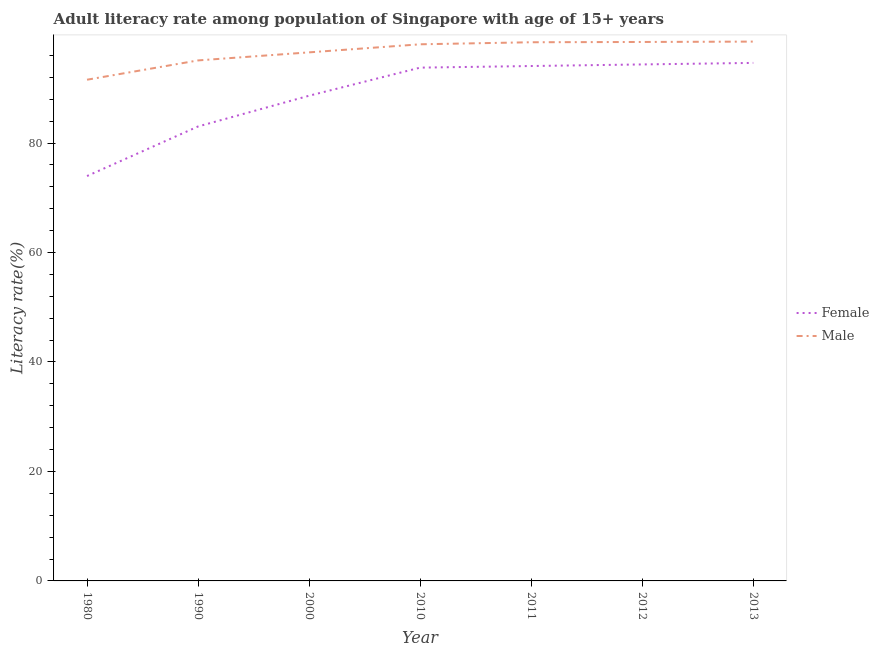How many different coloured lines are there?
Offer a terse response. 2. Is the number of lines equal to the number of legend labels?
Give a very brief answer. Yes. What is the male adult literacy rate in 2011?
Offer a terse response. 98.41. Across all years, what is the maximum female adult literacy rate?
Provide a short and direct response. 94.64. Across all years, what is the minimum female adult literacy rate?
Ensure brevity in your answer.  73.97. In which year was the female adult literacy rate maximum?
Keep it short and to the point. 2013. In which year was the male adult literacy rate minimum?
Offer a terse response. 1980. What is the total male adult literacy rate in the graph?
Offer a very short reply. 676.67. What is the difference between the male adult literacy rate in 2011 and that in 2012?
Provide a succinct answer. -0.05. What is the difference between the female adult literacy rate in 2012 and the male adult literacy rate in 2000?
Offer a terse response. -2.21. What is the average female adult literacy rate per year?
Provide a succinct answer. 88.93. In the year 2011, what is the difference between the male adult literacy rate and female adult literacy rate?
Give a very brief answer. 4.34. What is the ratio of the male adult literacy rate in 2011 to that in 2013?
Offer a very short reply. 1. Is the difference between the female adult literacy rate in 1980 and 2000 greater than the difference between the male adult literacy rate in 1980 and 2000?
Offer a very short reply. No. What is the difference between the highest and the second highest female adult literacy rate?
Provide a succinct answer. 0.28. What is the difference between the highest and the lowest male adult literacy rate?
Keep it short and to the point. 6.96. In how many years, is the male adult literacy rate greater than the average male adult literacy rate taken over all years?
Give a very brief answer. 4. Does the male adult literacy rate monotonically increase over the years?
Offer a terse response. Yes. Is the male adult literacy rate strictly greater than the female adult literacy rate over the years?
Give a very brief answer. Yes. Is the female adult literacy rate strictly less than the male adult literacy rate over the years?
Offer a terse response. Yes. How many lines are there?
Keep it short and to the point. 2. What is the difference between two consecutive major ticks on the Y-axis?
Your answer should be very brief. 20. Where does the legend appear in the graph?
Your response must be concise. Center right. How are the legend labels stacked?
Provide a succinct answer. Vertical. What is the title of the graph?
Your answer should be compact. Adult literacy rate among population of Singapore with age of 15+ years. What is the label or title of the X-axis?
Provide a short and direct response. Year. What is the label or title of the Y-axis?
Offer a very short reply. Literacy rate(%). What is the Literacy rate(%) in Female in 1980?
Provide a short and direct response. 73.97. What is the Literacy rate(%) of Male in 1980?
Give a very brief answer. 91.57. What is the Literacy rate(%) of Female in 1990?
Offer a very short reply. 83.03. What is the Literacy rate(%) in Male in 1990?
Offer a very short reply. 95.09. What is the Literacy rate(%) of Female in 2000?
Your answer should be very brief. 88.65. What is the Literacy rate(%) in Male in 2000?
Provide a succinct answer. 96.57. What is the Literacy rate(%) of Female in 2010?
Your response must be concise. 93.77. What is the Literacy rate(%) in Male in 2010?
Your answer should be compact. 98.04. What is the Literacy rate(%) in Female in 2011?
Keep it short and to the point. 94.07. What is the Literacy rate(%) in Male in 2011?
Ensure brevity in your answer.  98.41. What is the Literacy rate(%) in Female in 2012?
Offer a terse response. 94.36. What is the Literacy rate(%) of Male in 2012?
Your answer should be very brief. 98.46. What is the Literacy rate(%) in Female in 2013?
Keep it short and to the point. 94.64. What is the Literacy rate(%) of Male in 2013?
Ensure brevity in your answer.  98.53. Across all years, what is the maximum Literacy rate(%) of Female?
Your answer should be compact. 94.64. Across all years, what is the maximum Literacy rate(%) of Male?
Give a very brief answer. 98.53. Across all years, what is the minimum Literacy rate(%) in Female?
Keep it short and to the point. 73.97. Across all years, what is the minimum Literacy rate(%) in Male?
Provide a succinct answer. 91.57. What is the total Literacy rate(%) of Female in the graph?
Your response must be concise. 622.48. What is the total Literacy rate(%) in Male in the graph?
Make the answer very short. 676.67. What is the difference between the Literacy rate(%) of Female in 1980 and that in 1990?
Give a very brief answer. -9.06. What is the difference between the Literacy rate(%) of Male in 1980 and that in 1990?
Make the answer very short. -3.53. What is the difference between the Literacy rate(%) in Female in 1980 and that in 2000?
Make the answer very short. -14.68. What is the difference between the Literacy rate(%) in Male in 1980 and that in 2000?
Make the answer very short. -5. What is the difference between the Literacy rate(%) of Female in 1980 and that in 2010?
Ensure brevity in your answer.  -19.81. What is the difference between the Literacy rate(%) of Male in 1980 and that in 2010?
Make the answer very short. -6.47. What is the difference between the Literacy rate(%) in Female in 1980 and that in 2011?
Your response must be concise. -20.1. What is the difference between the Literacy rate(%) of Male in 1980 and that in 2011?
Make the answer very short. -6.85. What is the difference between the Literacy rate(%) of Female in 1980 and that in 2012?
Provide a short and direct response. -20.39. What is the difference between the Literacy rate(%) of Male in 1980 and that in 2012?
Offer a very short reply. -6.9. What is the difference between the Literacy rate(%) in Female in 1980 and that in 2013?
Give a very brief answer. -20.67. What is the difference between the Literacy rate(%) in Male in 1980 and that in 2013?
Give a very brief answer. -6.96. What is the difference between the Literacy rate(%) in Female in 1990 and that in 2000?
Give a very brief answer. -5.62. What is the difference between the Literacy rate(%) of Male in 1990 and that in 2000?
Your answer should be compact. -1.47. What is the difference between the Literacy rate(%) of Female in 1990 and that in 2010?
Offer a very short reply. -10.75. What is the difference between the Literacy rate(%) in Male in 1990 and that in 2010?
Your answer should be very brief. -2.94. What is the difference between the Literacy rate(%) of Female in 1990 and that in 2011?
Your response must be concise. -11.04. What is the difference between the Literacy rate(%) in Male in 1990 and that in 2011?
Ensure brevity in your answer.  -3.32. What is the difference between the Literacy rate(%) in Female in 1990 and that in 2012?
Give a very brief answer. -11.33. What is the difference between the Literacy rate(%) of Male in 1990 and that in 2012?
Ensure brevity in your answer.  -3.37. What is the difference between the Literacy rate(%) of Female in 1990 and that in 2013?
Ensure brevity in your answer.  -11.61. What is the difference between the Literacy rate(%) in Male in 1990 and that in 2013?
Give a very brief answer. -3.44. What is the difference between the Literacy rate(%) in Female in 2000 and that in 2010?
Provide a succinct answer. -5.13. What is the difference between the Literacy rate(%) of Male in 2000 and that in 2010?
Ensure brevity in your answer.  -1.47. What is the difference between the Literacy rate(%) of Female in 2000 and that in 2011?
Offer a terse response. -5.42. What is the difference between the Literacy rate(%) in Male in 2000 and that in 2011?
Give a very brief answer. -1.85. What is the difference between the Literacy rate(%) of Female in 2000 and that in 2012?
Provide a short and direct response. -5.71. What is the difference between the Literacy rate(%) in Male in 2000 and that in 2012?
Offer a very short reply. -1.9. What is the difference between the Literacy rate(%) of Female in 2000 and that in 2013?
Give a very brief answer. -5.99. What is the difference between the Literacy rate(%) in Male in 2000 and that in 2013?
Your answer should be compact. -1.97. What is the difference between the Literacy rate(%) in Female in 2010 and that in 2011?
Offer a terse response. -0.29. What is the difference between the Literacy rate(%) in Male in 2010 and that in 2011?
Your response must be concise. -0.37. What is the difference between the Literacy rate(%) of Female in 2010 and that in 2012?
Provide a short and direct response. -0.58. What is the difference between the Literacy rate(%) of Male in 2010 and that in 2012?
Your response must be concise. -0.43. What is the difference between the Literacy rate(%) of Female in 2010 and that in 2013?
Offer a very short reply. -0.86. What is the difference between the Literacy rate(%) in Male in 2010 and that in 2013?
Offer a terse response. -0.49. What is the difference between the Literacy rate(%) in Female in 2011 and that in 2012?
Offer a terse response. -0.29. What is the difference between the Literacy rate(%) in Male in 2011 and that in 2012?
Provide a short and direct response. -0.05. What is the difference between the Literacy rate(%) of Female in 2011 and that in 2013?
Ensure brevity in your answer.  -0.57. What is the difference between the Literacy rate(%) in Male in 2011 and that in 2013?
Your response must be concise. -0.12. What is the difference between the Literacy rate(%) of Female in 2012 and that in 2013?
Your response must be concise. -0.28. What is the difference between the Literacy rate(%) in Male in 2012 and that in 2013?
Offer a very short reply. -0.07. What is the difference between the Literacy rate(%) in Female in 1980 and the Literacy rate(%) in Male in 1990?
Provide a short and direct response. -21.12. What is the difference between the Literacy rate(%) in Female in 1980 and the Literacy rate(%) in Male in 2000?
Your answer should be very brief. -22.6. What is the difference between the Literacy rate(%) of Female in 1980 and the Literacy rate(%) of Male in 2010?
Offer a very short reply. -24.07. What is the difference between the Literacy rate(%) of Female in 1980 and the Literacy rate(%) of Male in 2011?
Provide a short and direct response. -24.44. What is the difference between the Literacy rate(%) in Female in 1980 and the Literacy rate(%) in Male in 2012?
Provide a short and direct response. -24.49. What is the difference between the Literacy rate(%) in Female in 1980 and the Literacy rate(%) in Male in 2013?
Offer a very short reply. -24.56. What is the difference between the Literacy rate(%) of Female in 1990 and the Literacy rate(%) of Male in 2000?
Offer a very short reply. -13.54. What is the difference between the Literacy rate(%) in Female in 1990 and the Literacy rate(%) in Male in 2010?
Keep it short and to the point. -15.01. What is the difference between the Literacy rate(%) of Female in 1990 and the Literacy rate(%) of Male in 2011?
Make the answer very short. -15.38. What is the difference between the Literacy rate(%) of Female in 1990 and the Literacy rate(%) of Male in 2012?
Make the answer very short. -15.44. What is the difference between the Literacy rate(%) of Female in 1990 and the Literacy rate(%) of Male in 2013?
Your answer should be compact. -15.5. What is the difference between the Literacy rate(%) of Female in 2000 and the Literacy rate(%) of Male in 2010?
Your answer should be very brief. -9.39. What is the difference between the Literacy rate(%) in Female in 2000 and the Literacy rate(%) in Male in 2011?
Your response must be concise. -9.77. What is the difference between the Literacy rate(%) of Female in 2000 and the Literacy rate(%) of Male in 2012?
Offer a terse response. -9.82. What is the difference between the Literacy rate(%) in Female in 2000 and the Literacy rate(%) in Male in 2013?
Provide a succinct answer. -9.89. What is the difference between the Literacy rate(%) in Female in 2010 and the Literacy rate(%) in Male in 2011?
Offer a very short reply. -4.64. What is the difference between the Literacy rate(%) of Female in 2010 and the Literacy rate(%) of Male in 2012?
Offer a very short reply. -4.69. What is the difference between the Literacy rate(%) of Female in 2010 and the Literacy rate(%) of Male in 2013?
Offer a terse response. -4.76. What is the difference between the Literacy rate(%) in Female in 2011 and the Literacy rate(%) in Male in 2012?
Offer a terse response. -4.39. What is the difference between the Literacy rate(%) of Female in 2011 and the Literacy rate(%) of Male in 2013?
Your answer should be compact. -4.46. What is the difference between the Literacy rate(%) in Female in 2012 and the Literacy rate(%) in Male in 2013?
Provide a short and direct response. -4.17. What is the average Literacy rate(%) of Female per year?
Your answer should be very brief. 88.93. What is the average Literacy rate(%) in Male per year?
Keep it short and to the point. 96.67. In the year 1980, what is the difference between the Literacy rate(%) in Female and Literacy rate(%) in Male?
Your response must be concise. -17.6. In the year 1990, what is the difference between the Literacy rate(%) in Female and Literacy rate(%) in Male?
Provide a short and direct response. -12.07. In the year 2000, what is the difference between the Literacy rate(%) in Female and Literacy rate(%) in Male?
Give a very brief answer. -7.92. In the year 2010, what is the difference between the Literacy rate(%) in Female and Literacy rate(%) in Male?
Your answer should be very brief. -4.26. In the year 2011, what is the difference between the Literacy rate(%) in Female and Literacy rate(%) in Male?
Your response must be concise. -4.34. In the year 2012, what is the difference between the Literacy rate(%) of Female and Literacy rate(%) of Male?
Your answer should be very brief. -4.1. In the year 2013, what is the difference between the Literacy rate(%) in Female and Literacy rate(%) in Male?
Your answer should be compact. -3.89. What is the ratio of the Literacy rate(%) of Female in 1980 to that in 1990?
Provide a succinct answer. 0.89. What is the ratio of the Literacy rate(%) of Male in 1980 to that in 1990?
Keep it short and to the point. 0.96. What is the ratio of the Literacy rate(%) of Female in 1980 to that in 2000?
Ensure brevity in your answer.  0.83. What is the ratio of the Literacy rate(%) in Male in 1980 to that in 2000?
Offer a terse response. 0.95. What is the ratio of the Literacy rate(%) in Female in 1980 to that in 2010?
Offer a very short reply. 0.79. What is the ratio of the Literacy rate(%) in Male in 1980 to that in 2010?
Keep it short and to the point. 0.93. What is the ratio of the Literacy rate(%) of Female in 1980 to that in 2011?
Provide a succinct answer. 0.79. What is the ratio of the Literacy rate(%) in Male in 1980 to that in 2011?
Your answer should be compact. 0.93. What is the ratio of the Literacy rate(%) in Female in 1980 to that in 2012?
Make the answer very short. 0.78. What is the ratio of the Literacy rate(%) of Female in 1980 to that in 2013?
Keep it short and to the point. 0.78. What is the ratio of the Literacy rate(%) in Male in 1980 to that in 2013?
Give a very brief answer. 0.93. What is the ratio of the Literacy rate(%) of Female in 1990 to that in 2000?
Your answer should be very brief. 0.94. What is the ratio of the Literacy rate(%) of Female in 1990 to that in 2010?
Your response must be concise. 0.89. What is the ratio of the Literacy rate(%) of Male in 1990 to that in 2010?
Keep it short and to the point. 0.97. What is the ratio of the Literacy rate(%) of Female in 1990 to that in 2011?
Give a very brief answer. 0.88. What is the ratio of the Literacy rate(%) of Male in 1990 to that in 2011?
Offer a very short reply. 0.97. What is the ratio of the Literacy rate(%) of Female in 1990 to that in 2012?
Your answer should be very brief. 0.88. What is the ratio of the Literacy rate(%) of Male in 1990 to that in 2012?
Provide a short and direct response. 0.97. What is the ratio of the Literacy rate(%) of Female in 1990 to that in 2013?
Ensure brevity in your answer.  0.88. What is the ratio of the Literacy rate(%) in Male in 1990 to that in 2013?
Provide a short and direct response. 0.97. What is the ratio of the Literacy rate(%) of Female in 2000 to that in 2010?
Offer a very short reply. 0.95. What is the ratio of the Literacy rate(%) of Female in 2000 to that in 2011?
Offer a very short reply. 0.94. What is the ratio of the Literacy rate(%) in Male in 2000 to that in 2011?
Your answer should be very brief. 0.98. What is the ratio of the Literacy rate(%) of Female in 2000 to that in 2012?
Keep it short and to the point. 0.94. What is the ratio of the Literacy rate(%) of Male in 2000 to that in 2012?
Make the answer very short. 0.98. What is the ratio of the Literacy rate(%) of Female in 2000 to that in 2013?
Your answer should be compact. 0.94. What is the ratio of the Literacy rate(%) of Male in 2000 to that in 2013?
Provide a succinct answer. 0.98. What is the ratio of the Literacy rate(%) in Male in 2010 to that in 2011?
Give a very brief answer. 1. What is the ratio of the Literacy rate(%) in Female in 2010 to that in 2012?
Ensure brevity in your answer.  0.99. What is the ratio of the Literacy rate(%) of Female in 2010 to that in 2013?
Ensure brevity in your answer.  0.99. What is the ratio of the Literacy rate(%) in Male in 2010 to that in 2013?
Offer a very short reply. 0.99. What is the ratio of the Literacy rate(%) in Female in 2012 to that in 2013?
Provide a succinct answer. 1. What is the ratio of the Literacy rate(%) in Male in 2012 to that in 2013?
Offer a very short reply. 1. What is the difference between the highest and the second highest Literacy rate(%) of Female?
Offer a terse response. 0.28. What is the difference between the highest and the second highest Literacy rate(%) of Male?
Provide a succinct answer. 0.07. What is the difference between the highest and the lowest Literacy rate(%) in Female?
Keep it short and to the point. 20.67. What is the difference between the highest and the lowest Literacy rate(%) of Male?
Offer a very short reply. 6.96. 